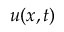<formula> <loc_0><loc_0><loc_500><loc_500>u ( x , t )</formula> 